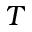<formula> <loc_0><loc_0><loc_500><loc_500>T</formula> 